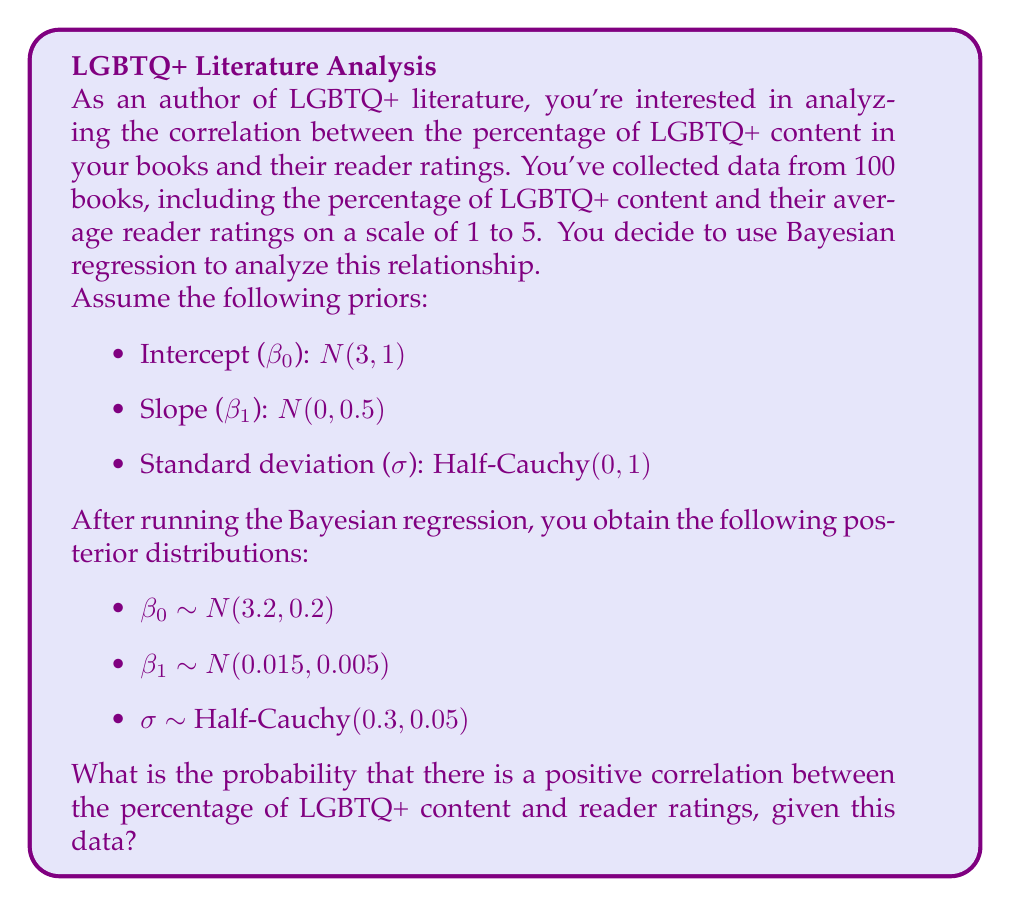Can you solve this math problem? To solve this problem, we need to focus on the posterior distribution of $\beta_1$, which represents the slope of the regression line. A positive $\beta_1$ indicates a positive correlation between LGBTQ+ content and reader ratings.

Given:
$\beta_1 \sim N(0.015, 0.005)$

Step 1: Calculate the z-score for $\beta_1 = 0$ (the point of no correlation):
$$z = \frac{0 - \mu}{\sigma} = \frac{0 - 0.015}{0.005} = -3$$

Step 2: Find the probability that $\beta_1 > 0$ using the standard normal distribution:
$$P(\beta_1 > 0) = 1 - \Phi(-3)$$

Where $\Phi$ is the cumulative distribution function of the standard normal distribution.

Step 3: Look up the value of $\Phi(-3)$ in a standard normal table or use a calculator:
$$\Phi(-3) \approx 0.00135$$

Step 4: Calculate the final probability:
$$P(\beta_1 > 0) = 1 - 0.00135 \approx 0.99865$$

Therefore, the probability that there is a positive correlation between the percentage of LGBTQ+ content and reader ratings, given this data, is approximately 0.99865 or 99.865%.
Answer: 0.99865 